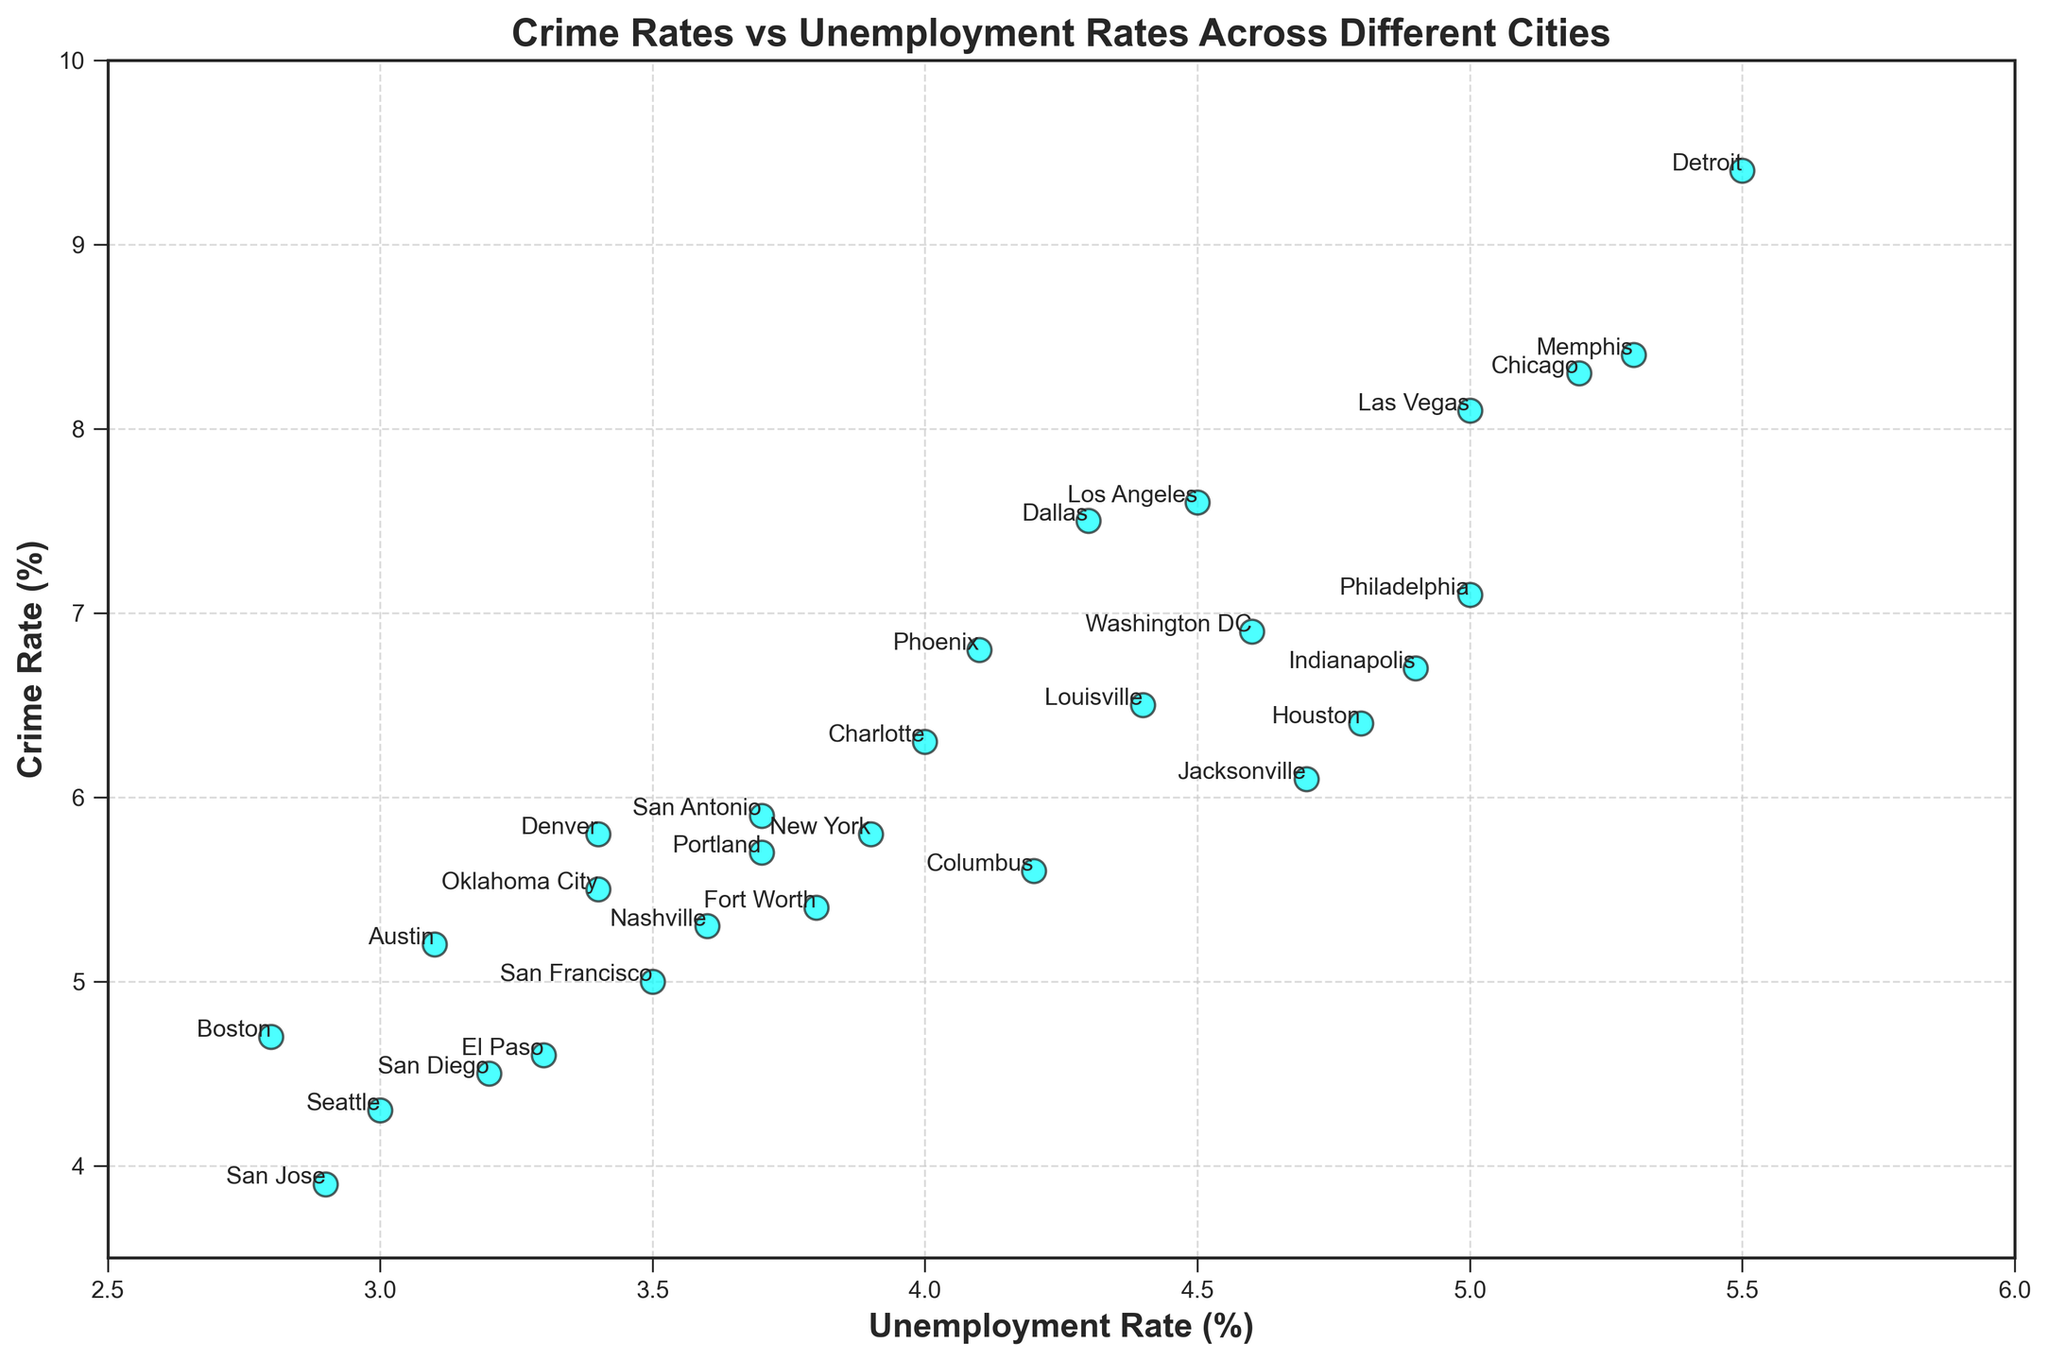What city has the highest crime rate? Look for the point with the highest y-axis value (Crime Rate). The highest point on the y-axis corresponds to Detroit.
Answer: Detroit Which city has the lowest unemployment rate? Locate the point with the lowest x-axis value (Unemployment Rate). The lowest point on the x-axis corresponds to San Jose.
Answer: San Jose Is there a city with a crime rate above 9%? Check for any points with a y-axis value greater than 9. The only city that satisfies this condition is Detroit.
Answer: Yes, Detroit Which city has a higher unemployment rate: New York or Houston? Find the two points corresponding to New York and Houston, then compare their x-axis values (Unemployment Rate). New York has an unemployment rate of 3.9, while Houston has 4.8.
Answer: Houston What is the range of crime rates in this dataset? Identify the lowest and highest points on the y-axis (Crime Rate). The lowest crime rate is San Jose's 3.9, and the highest is Detroit's 9.4. The range is 9.4 - 3.9.
Answer: 5.5% Is there any city in the dataset with both a crime rate below 5% and an unemployment rate below 3%? Look for a point that satisfies both conditions: y-axis value below 5 and x-axis value below 3. San Jose has a crime rate of 3.9% and an unemployment rate of 2.9%.
Answer: Yes, San Jose Which cities have crime rates similar to Philadelphia? Find Philadelphia on the plot with a crime rate of 7.1%, then identify nearby points on the y-axis. Nearby cities include Indianapolis and Washington DC.
Answer: Indianapolis, Washington DC How many cities have a crime rate between 5% and 7%? Count the points that fall within the y-axis range of 5 to 7. The cities with crime rates in this range are New York, San Antonio, Austin, Fort Worth, Columbus, San Francisco, Denver, and Portland. There are 8 cities in total.
Answer: 8 What is the average unemployment rate of cities with crime rates above 8%? Identify cities with y-axis values (Crime Rate) above 8. The cities are Chicago, Las Vegas, Memphis, Detroit. The unemployment rates are 5.2, 5.0, 5.3, and 5.5 respectively. Calculate (5.2 + 5.0 + 5.3 + 5.5) / 4 = 5.25.
Answer: 5.25% Which city has a lower crime rate but a higher unemployment rate than Los Angeles? Compare Los Angeles' values (Crime Rate 7.6 and Unemployment Rate 4.5) and find cities with lower y-axis values and higher x-axis values. No cities meet these criteria.
Answer: None 